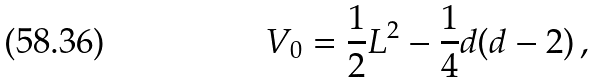Convert formula to latex. <formula><loc_0><loc_0><loc_500><loc_500>V _ { 0 } = \frac { 1 } { 2 } L ^ { 2 } - \frac { 1 } { 4 } d ( d - 2 ) \, ,</formula> 